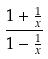Convert formula to latex. <formula><loc_0><loc_0><loc_500><loc_500>\frac { 1 + \frac { 1 } { x } } { 1 - \frac { 1 } { x } }</formula> 